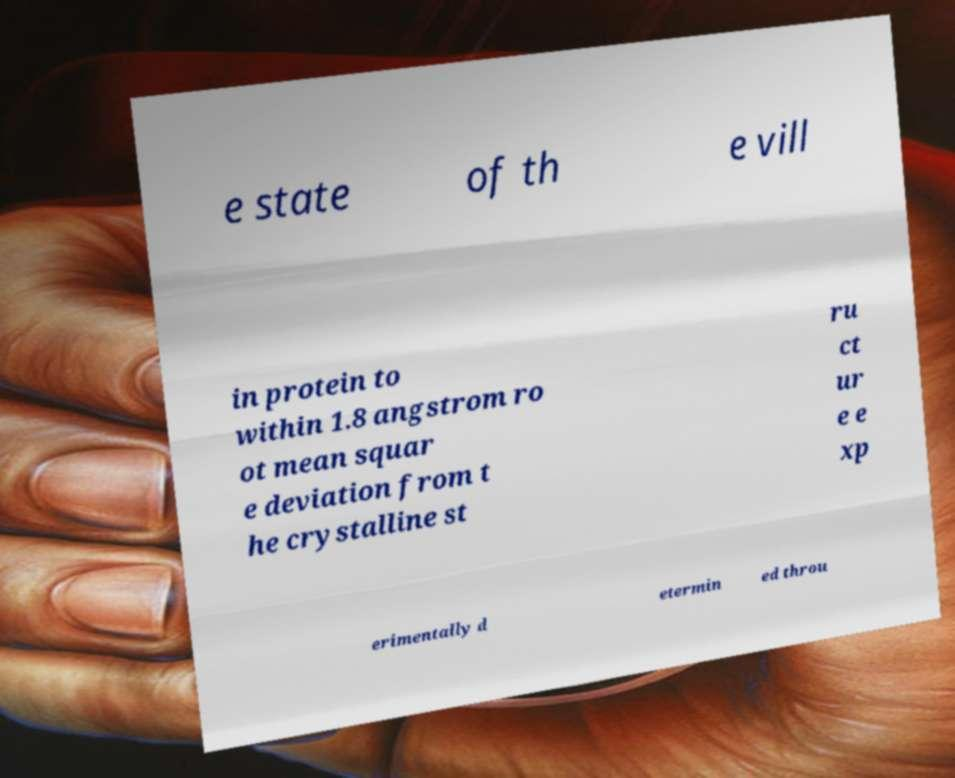Can you read and provide the text displayed in the image?This photo seems to have some interesting text. Can you extract and type it out for me? e state of th e vill in protein to within 1.8 angstrom ro ot mean squar e deviation from t he crystalline st ru ct ur e e xp erimentally d etermin ed throu 